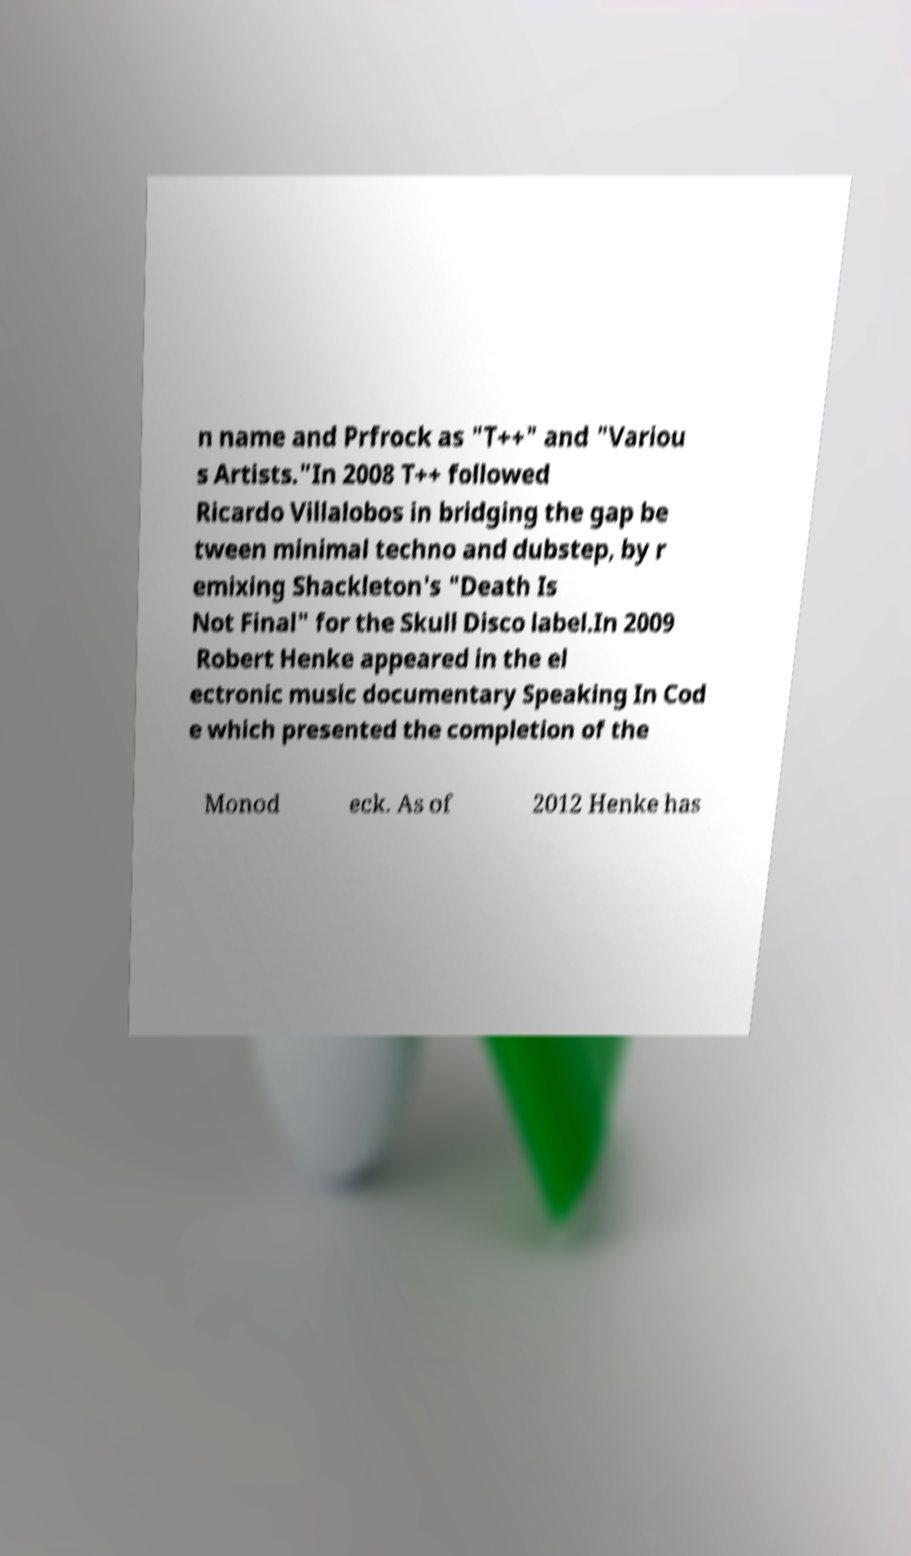Can you accurately transcribe the text from the provided image for me? n name and Prfrock as "T++" and "Variou s Artists."In 2008 T++ followed Ricardo Villalobos in bridging the gap be tween minimal techno and dubstep, by r emixing Shackleton's "Death Is Not Final" for the Skull Disco label.In 2009 Robert Henke appeared in the el ectronic music documentary Speaking In Cod e which presented the completion of the Monod eck. As of 2012 Henke has 